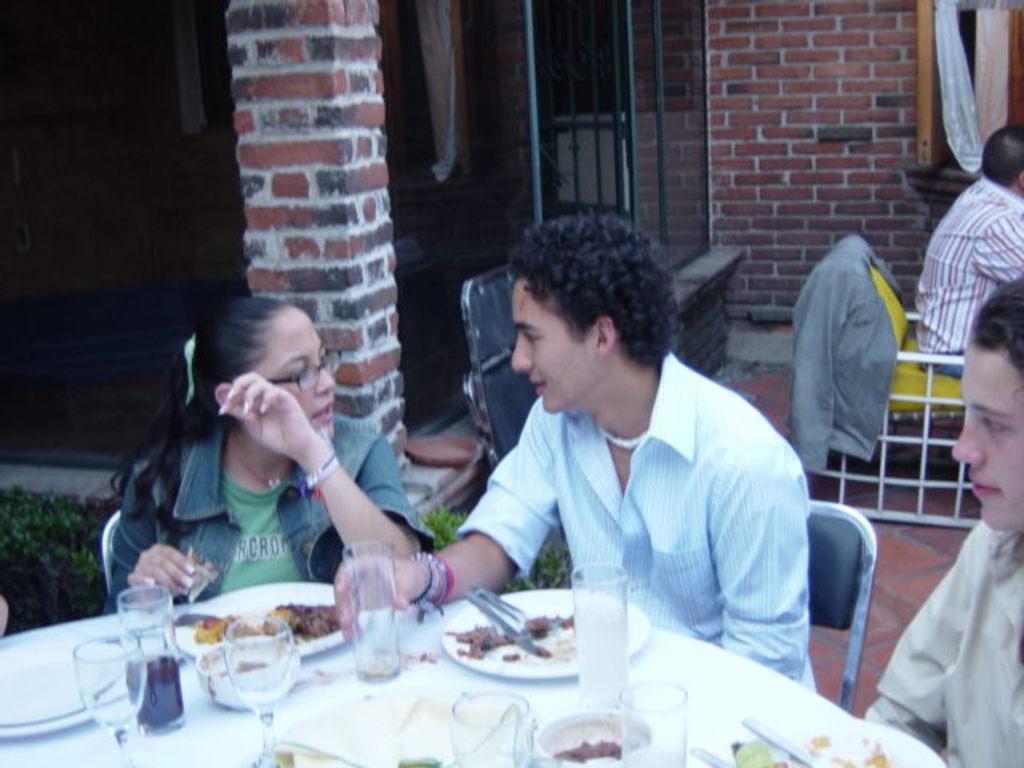How would you summarize this image in a sentence or two? people are sitting on chairs and having food. in front of them there is a table on which there are glasses, plates. behind him there is a building of bricks. 